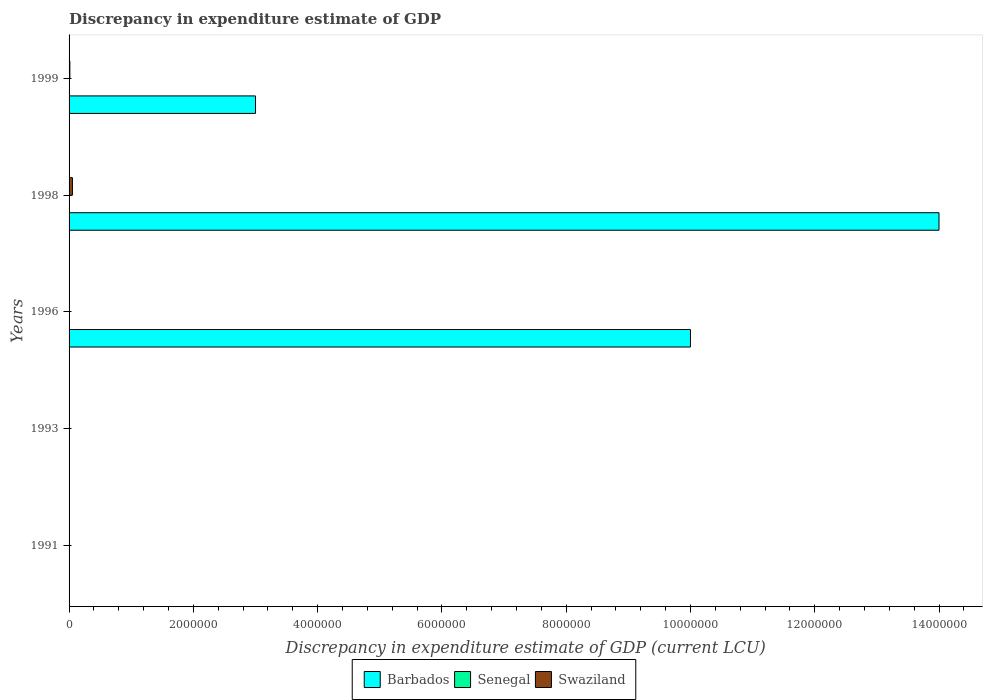Are the number of bars per tick equal to the number of legend labels?
Keep it short and to the point. No. How many bars are there on the 4th tick from the top?
Offer a terse response. 1. How many bars are there on the 2nd tick from the bottom?
Your response must be concise. 1. What is the discrepancy in expenditure estimate of GDP in Swaziland in 1996?
Make the answer very short. 100. Across all years, what is the maximum discrepancy in expenditure estimate of GDP in Senegal?
Keep it short and to the point. 100. In which year was the discrepancy in expenditure estimate of GDP in Senegal maximum?
Your answer should be very brief. 1998. What is the total discrepancy in expenditure estimate of GDP in Barbados in the graph?
Your answer should be very brief. 2.70e+07. What is the difference between the discrepancy in expenditure estimate of GDP in Barbados in 1996 and that in 1998?
Keep it short and to the point. -4.00e+06. What is the difference between the discrepancy in expenditure estimate of GDP in Senegal in 1996 and the discrepancy in expenditure estimate of GDP in Barbados in 1991?
Give a very brief answer. 0. What is the average discrepancy in expenditure estimate of GDP in Barbados per year?
Make the answer very short. 5.40e+06. In the year 1999, what is the difference between the discrepancy in expenditure estimate of GDP in Swaziland and discrepancy in expenditure estimate of GDP in Barbados?
Keep it short and to the point. -2.99e+06. What is the ratio of the discrepancy in expenditure estimate of GDP in Swaziland in 1991 to that in 1999?
Your answer should be compact. 4.76190476175359e-12. Is the discrepancy in expenditure estimate of GDP in Swaziland in 1996 less than that in 1999?
Provide a succinct answer. Yes. Is the difference between the discrepancy in expenditure estimate of GDP in Swaziland in 1998 and 1999 greater than the difference between the discrepancy in expenditure estimate of GDP in Barbados in 1998 and 1999?
Make the answer very short. No. What is the difference between the highest and the lowest discrepancy in expenditure estimate of GDP in Swaziland?
Provide a short and direct response. 5.41e+04. In how many years, is the discrepancy in expenditure estimate of GDP in Barbados greater than the average discrepancy in expenditure estimate of GDP in Barbados taken over all years?
Your answer should be compact. 2. Does the graph contain grids?
Give a very brief answer. No. Where does the legend appear in the graph?
Offer a very short reply. Bottom center. How many legend labels are there?
Offer a very short reply. 3. How are the legend labels stacked?
Keep it short and to the point. Horizontal. What is the title of the graph?
Your answer should be very brief. Discrepancy in expenditure estimate of GDP. Does "Djibouti" appear as one of the legend labels in the graph?
Your answer should be very brief. No. What is the label or title of the X-axis?
Give a very brief answer. Discrepancy in expenditure estimate of GDP (current LCU). What is the Discrepancy in expenditure estimate of GDP (current LCU) of Senegal in 1991?
Your response must be concise. 100. What is the Discrepancy in expenditure estimate of GDP (current LCU) of Swaziland in 1991?
Your answer should be compact. 6e-8. What is the Discrepancy in expenditure estimate of GDP (current LCU) in Barbados in 1993?
Offer a very short reply. 0. What is the Discrepancy in expenditure estimate of GDP (current LCU) of Senegal in 1993?
Keep it short and to the point. 0. What is the Discrepancy in expenditure estimate of GDP (current LCU) in Swaziland in 1993?
Provide a short and direct response. 1.2e-7. What is the Discrepancy in expenditure estimate of GDP (current LCU) of Barbados in 1996?
Your answer should be compact. 1.00e+07. What is the Discrepancy in expenditure estimate of GDP (current LCU) of Senegal in 1996?
Provide a short and direct response. 0. What is the Discrepancy in expenditure estimate of GDP (current LCU) in Swaziland in 1996?
Offer a terse response. 100. What is the Discrepancy in expenditure estimate of GDP (current LCU) in Barbados in 1998?
Make the answer very short. 1.40e+07. What is the Discrepancy in expenditure estimate of GDP (current LCU) in Senegal in 1998?
Provide a short and direct response. 100. What is the Discrepancy in expenditure estimate of GDP (current LCU) of Swaziland in 1998?
Your answer should be very brief. 5.41e+04. What is the Discrepancy in expenditure estimate of GDP (current LCU) in Barbados in 1999?
Your answer should be very brief. 3.00e+06. What is the Discrepancy in expenditure estimate of GDP (current LCU) of Swaziland in 1999?
Your answer should be very brief. 1.26e+04. Across all years, what is the maximum Discrepancy in expenditure estimate of GDP (current LCU) of Barbados?
Ensure brevity in your answer.  1.40e+07. Across all years, what is the maximum Discrepancy in expenditure estimate of GDP (current LCU) of Senegal?
Give a very brief answer. 100. Across all years, what is the maximum Discrepancy in expenditure estimate of GDP (current LCU) of Swaziland?
Give a very brief answer. 5.41e+04. Across all years, what is the minimum Discrepancy in expenditure estimate of GDP (current LCU) of Swaziland?
Make the answer very short. 6e-8. What is the total Discrepancy in expenditure estimate of GDP (current LCU) of Barbados in the graph?
Your answer should be very brief. 2.70e+07. What is the total Discrepancy in expenditure estimate of GDP (current LCU) of Senegal in the graph?
Your response must be concise. 200. What is the total Discrepancy in expenditure estimate of GDP (current LCU) of Swaziland in the graph?
Provide a short and direct response. 6.68e+04. What is the difference between the Discrepancy in expenditure estimate of GDP (current LCU) of Senegal in 1991 and that in 1996?
Your response must be concise. 100. What is the difference between the Discrepancy in expenditure estimate of GDP (current LCU) of Swaziland in 1991 and that in 1996?
Provide a short and direct response. -100. What is the difference between the Discrepancy in expenditure estimate of GDP (current LCU) in Senegal in 1991 and that in 1998?
Ensure brevity in your answer.  -0. What is the difference between the Discrepancy in expenditure estimate of GDP (current LCU) in Swaziland in 1991 and that in 1998?
Your response must be concise. -5.41e+04. What is the difference between the Discrepancy in expenditure estimate of GDP (current LCU) in Swaziland in 1991 and that in 1999?
Give a very brief answer. -1.26e+04. What is the difference between the Discrepancy in expenditure estimate of GDP (current LCU) in Swaziland in 1993 and that in 1996?
Ensure brevity in your answer.  -100. What is the difference between the Discrepancy in expenditure estimate of GDP (current LCU) in Swaziland in 1993 and that in 1998?
Provide a short and direct response. -5.41e+04. What is the difference between the Discrepancy in expenditure estimate of GDP (current LCU) in Swaziland in 1993 and that in 1999?
Your answer should be very brief. -1.26e+04. What is the difference between the Discrepancy in expenditure estimate of GDP (current LCU) of Barbados in 1996 and that in 1998?
Offer a very short reply. -4.00e+06. What is the difference between the Discrepancy in expenditure estimate of GDP (current LCU) in Senegal in 1996 and that in 1998?
Make the answer very short. -100. What is the difference between the Discrepancy in expenditure estimate of GDP (current LCU) in Swaziland in 1996 and that in 1998?
Make the answer very short. -5.40e+04. What is the difference between the Discrepancy in expenditure estimate of GDP (current LCU) of Barbados in 1996 and that in 1999?
Keep it short and to the point. 7.00e+06. What is the difference between the Discrepancy in expenditure estimate of GDP (current LCU) in Swaziland in 1996 and that in 1999?
Make the answer very short. -1.25e+04. What is the difference between the Discrepancy in expenditure estimate of GDP (current LCU) of Barbados in 1998 and that in 1999?
Offer a very short reply. 1.10e+07. What is the difference between the Discrepancy in expenditure estimate of GDP (current LCU) in Swaziland in 1998 and that in 1999?
Ensure brevity in your answer.  4.15e+04. What is the difference between the Discrepancy in expenditure estimate of GDP (current LCU) in Senegal in 1991 and the Discrepancy in expenditure estimate of GDP (current LCU) in Swaziland in 1996?
Keep it short and to the point. 0. What is the difference between the Discrepancy in expenditure estimate of GDP (current LCU) in Senegal in 1991 and the Discrepancy in expenditure estimate of GDP (current LCU) in Swaziland in 1998?
Give a very brief answer. -5.40e+04. What is the difference between the Discrepancy in expenditure estimate of GDP (current LCU) in Senegal in 1991 and the Discrepancy in expenditure estimate of GDP (current LCU) in Swaziland in 1999?
Offer a very short reply. -1.25e+04. What is the difference between the Discrepancy in expenditure estimate of GDP (current LCU) in Barbados in 1996 and the Discrepancy in expenditure estimate of GDP (current LCU) in Senegal in 1998?
Give a very brief answer. 1.00e+07. What is the difference between the Discrepancy in expenditure estimate of GDP (current LCU) in Barbados in 1996 and the Discrepancy in expenditure estimate of GDP (current LCU) in Swaziland in 1998?
Provide a short and direct response. 9.95e+06. What is the difference between the Discrepancy in expenditure estimate of GDP (current LCU) of Senegal in 1996 and the Discrepancy in expenditure estimate of GDP (current LCU) of Swaziland in 1998?
Provide a succinct answer. -5.41e+04. What is the difference between the Discrepancy in expenditure estimate of GDP (current LCU) in Barbados in 1996 and the Discrepancy in expenditure estimate of GDP (current LCU) in Swaziland in 1999?
Keep it short and to the point. 9.99e+06. What is the difference between the Discrepancy in expenditure estimate of GDP (current LCU) in Senegal in 1996 and the Discrepancy in expenditure estimate of GDP (current LCU) in Swaziland in 1999?
Offer a very short reply. -1.26e+04. What is the difference between the Discrepancy in expenditure estimate of GDP (current LCU) in Barbados in 1998 and the Discrepancy in expenditure estimate of GDP (current LCU) in Swaziland in 1999?
Your response must be concise. 1.40e+07. What is the difference between the Discrepancy in expenditure estimate of GDP (current LCU) of Senegal in 1998 and the Discrepancy in expenditure estimate of GDP (current LCU) of Swaziland in 1999?
Ensure brevity in your answer.  -1.25e+04. What is the average Discrepancy in expenditure estimate of GDP (current LCU) of Barbados per year?
Your answer should be very brief. 5.40e+06. What is the average Discrepancy in expenditure estimate of GDP (current LCU) in Senegal per year?
Your answer should be very brief. 40. What is the average Discrepancy in expenditure estimate of GDP (current LCU) of Swaziland per year?
Give a very brief answer. 1.34e+04. In the year 1996, what is the difference between the Discrepancy in expenditure estimate of GDP (current LCU) of Barbados and Discrepancy in expenditure estimate of GDP (current LCU) of Senegal?
Provide a short and direct response. 1.00e+07. In the year 1996, what is the difference between the Discrepancy in expenditure estimate of GDP (current LCU) in Barbados and Discrepancy in expenditure estimate of GDP (current LCU) in Swaziland?
Make the answer very short. 1.00e+07. In the year 1996, what is the difference between the Discrepancy in expenditure estimate of GDP (current LCU) in Senegal and Discrepancy in expenditure estimate of GDP (current LCU) in Swaziland?
Your answer should be compact. -100. In the year 1998, what is the difference between the Discrepancy in expenditure estimate of GDP (current LCU) of Barbados and Discrepancy in expenditure estimate of GDP (current LCU) of Senegal?
Give a very brief answer. 1.40e+07. In the year 1998, what is the difference between the Discrepancy in expenditure estimate of GDP (current LCU) of Barbados and Discrepancy in expenditure estimate of GDP (current LCU) of Swaziland?
Offer a terse response. 1.39e+07. In the year 1998, what is the difference between the Discrepancy in expenditure estimate of GDP (current LCU) in Senegal and Discrepancy in expenditure estimate of GDP (current LCU) in Swaziland?
Your answer should be very brief. -5.40e+04. In the year 1999, what is the difference between the Discrepancy in expenditure estimate of GDP (current LCU) in Barbados and Discrepancy in expenditure estimate of GDP (current LCU) in Swaziland?
Your response must be concise. 2.99e+06. What is the ratio of the Discrepancy in expenditure estimate of GDP (current LCU) of Senegal in 1991 to that in 1996?
Keep it short and to the point. 1.14e+05. What is the ratio of the Discrepancy in expenditure estimate of GDP (current LCU) in Senegal in 1991 to that in 1998?
Your answer should be very brief. 1. What is the ratio of the Discrepancy in expenditure estimate of GDP (current LCU) of Swaziland in 1991 to that in 1999?
Provide a succinct answer. 0. What is the ratio of the Discrepancy in expenditure estimate of GDP (current LCU) in Swaziland in 1993 to that in 1996?
Ensure brevity in your answer.  0. What is the ratio of the Discrepancy in expenditure estimate of GDP (current LCU) in Swaziland in 1993 to that in 1998?
Ensure brevity in your answer.  0. What is the ratio of the Discrepancy in expenditure estimate of GDP (current LCU) in Swaziland in 1993 to that in 1999?
Ensure brevity in your answer.  0. What is the ratio of the Discrepancy in expenditure estimate of GDP (current LCU) of Swaziland in 1996 to that in 1998?
Provide a succinct answer. 0. What is the ratio of the Discrepancy in expenditure estimate of GDP (current LCU) in Swaziland in 1996 to that in 1999?
Make the answer very short. 0.01. What is the ratio of the Discrepancy in expenditure estimate of GDP (current LCU) in Barbados in 1998 to that in 1999?
Your answer should be very brief. 4.67. What is the ratio of the Discrepancy in expenditure estimate of GDP (current LCU) in Swaziland in 1998 to that in 1999?
Provide a succinct answer. 4.29. What is the difference between the highest and the second highest Discrepancy in expenditure estimate of GDP (current LCU) in Barbados?
Your response must be concise. 4.00e+06. What is the difference between the highest and the second highest Discrepancy in expenditure estimate of GDP (current LCU) in Senegal?
Offer a very short reply. 0. What is the difference between the highest and the second highest Discrepancy in expenditure estimate of GDP (current LCU) in Swaziland?
Offer a very short reply. 4.15e+04. What is the difference between the highest and the lowest Discrepancy in expenditure estimate of GDP (current LCU) of Barbados?
Your answer should be very brief. 1.40e+07. What is the difference between the highest and the lowest Discrepancy in expenditure estimate of GDP (current LCU) in Senegal?
Provide a succinct answer. 100. What is the difference between the highest and the lowest Discrepancy in expenditure estimate of GDP (current LCU) of Swaziland?
Offer a very short reply. 5.41e+04. 